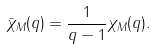Convert formula to latex. <formula><loc_0><loc_0><loc_500><loc_500>\bar { \chi } _ { M } ( q ) = \frac { 1 } { q - 1 } \chi _ { M } ( q ) .</formula> 